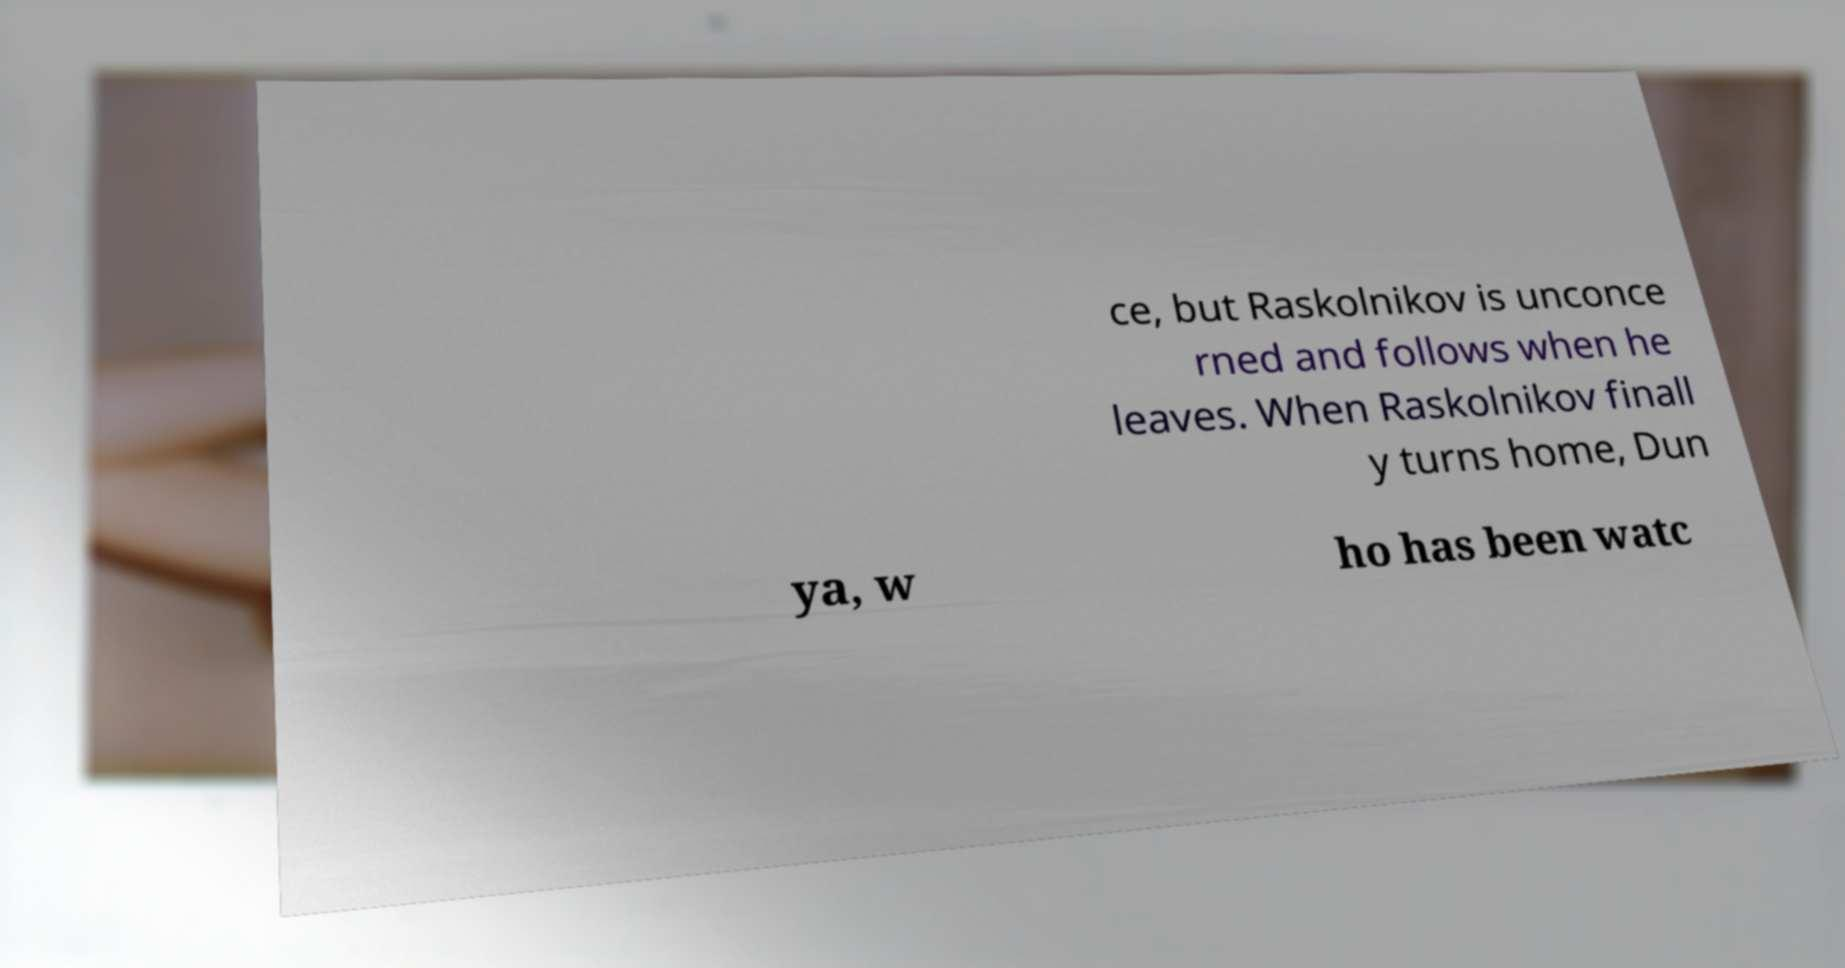Can you accurately transcribe the text from the provided image for me? ce, but Raskolnikov is unconce rned and follows when he leaves. When Raskolnikov finall y turns home, Dun ya, w ho has been watc 